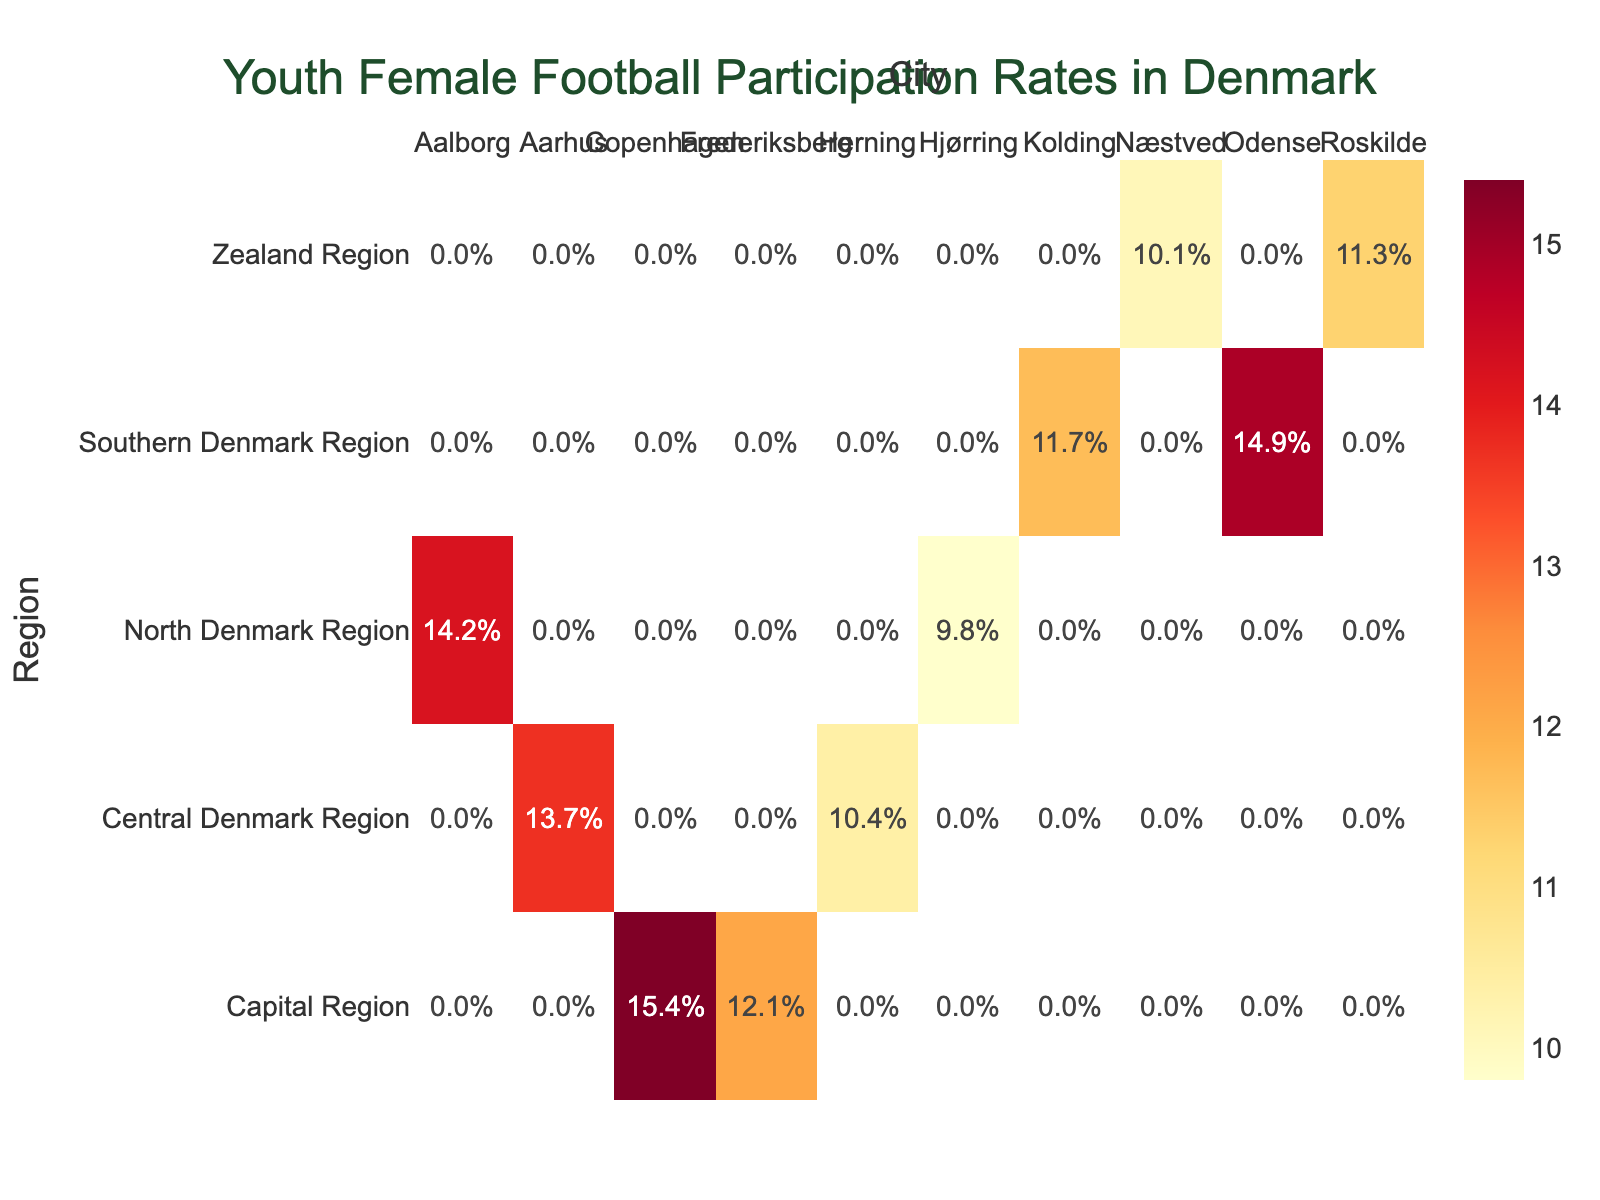What is the highest youth female football participation rate shown on the heatmap? The highest participation rate can be identified by looking at the value with the darkest color, which is the color representing the highest value in the 'YlOrRd' color scale. The value shown is 15.4%, which corresponds to Copenhagen in the Capital Region.
Answer: 15.4% What is the participation rate in Odense? Find "Odense" on the x-axis and then look at the corresponding heatmap value. It shows a participation rate of 14.9%.
Answer: 14.9% Which city in the Central Denmark Region has the higher participation rate? Look at the values for Aarhus and Herning in the Central Denmark Region. Aarhus has a rate of 13.7% and Herning has a rate of 10.4%. Compare these two rates to see which one is higher.
Answer: Aarhus How many regions have at least one city with a participation rate below 12%? Look at the heatmap and identify regions where at least one city's participation rate is below 12%. The regions are: Capital Region (Frederiksberg, 12.1%), Central Denmark Region (Herning, 10.4%), North Denmark Region (Hjørring, 9.8%), Southern Denmark Region (Kolding, 11.7%), and Zealand Region (Roskilde, 11.3%, Næstved, 10.1%). This results in 5 regions.
Answer: 5 What is the average participation rate in the Zealand Region? Identify the participation rates in the cities (Roskilde and Næstved) in the Zealand Region. Sum these values (11.3% + 10.1% = 21.4%) and divide by the number of cities (2). The result is 21.4% / 2 = 10.7%.
Answer: 10.7% What is the participation rate in Hjørring? Locate "Hjørring" on the x-axis and then check the corresponding value. It shows a 9.8% participation rate.
Answer: 9.8% Do any two cities have the same participation rate? Compare all values shown on the heatmap. No two cities have identical participation rates; all rates are unique. Thus, no cities share the same participation rate.
Answer: No 